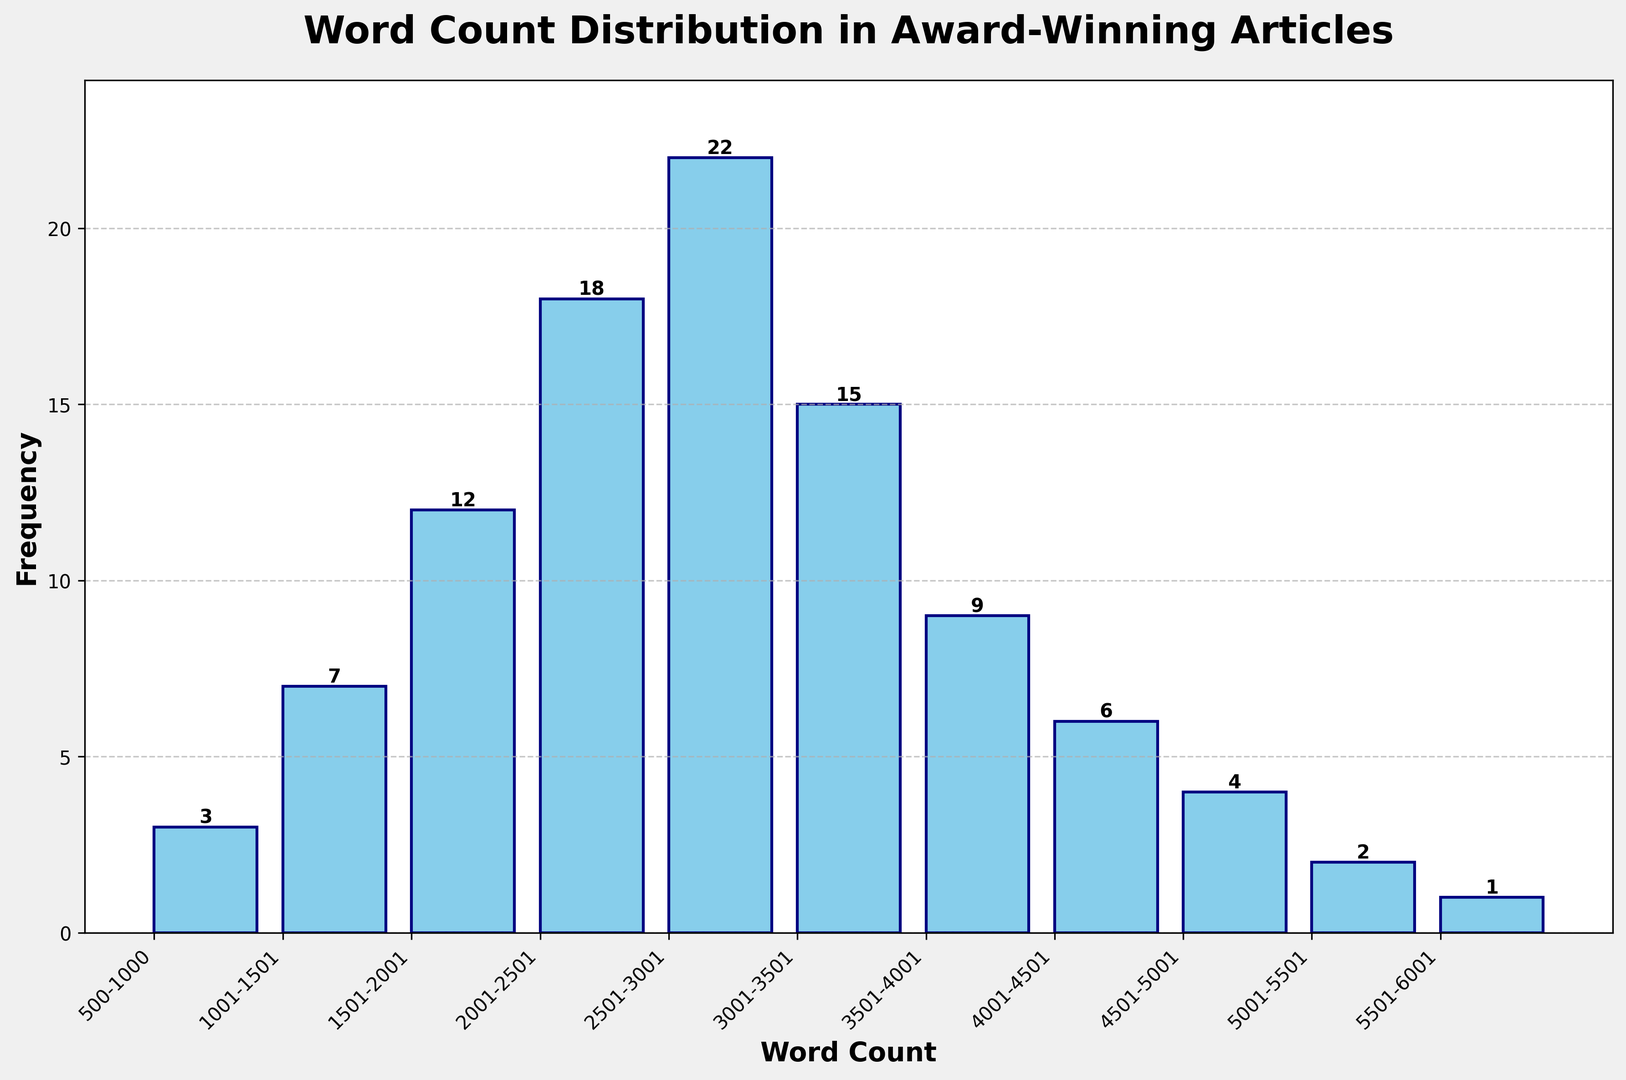What is the most frequent word count range? The bar representing the word count range 2501-3000 is the tallest, which means it has the highest frequency.
Answer: 2501-3000 What is the total frequency of articles with word counts between 1501 and 2500? Sum the frequencies of the ranges 1501-2000 (12 articles) and 2001-2500 (18 articles), which results in 12 + 18 = 30 articles.
Answer: 30 Are there more articles with word counts between 3001-4000 or 1001-2000? Compare the frequencies of ranges 3001-3500 (15 articles) and 3501-4000 (9 articles) to the frequencies of 1001-1500 (7 articles) and 1501-2000 (12 articles). Total for 3001-4000 is 15 + 9 = 24, while total for 1001-2000 is 7 + 12 = 19.
Answer: 3001-4000 What is the frequency of the shortest word count range? The smallest word count range 500-1000 has the shortest bar with a frequency of 3 articles.
Answer: 3 Which word count range appears to decline the most in frequency compared to its immediate previous range? Observe the bars and see that the range 3001-3500 (15 articles) followed by 3501-4000 (9 articles) has the largest drop of 15 - 9 = 6 articles.
Answer: 3501-4000 What is the average word count range frequency? Sum all the frequencies: (3 + 7 + 12 + 18 + 22 + 15 + 9 + 6 + 4 + 2 + 1 = 99 articles), then divide by the number of ranges (11). The average is 99 / 11 ≈ 9 articles.
Answer: 9 How many word count ranges have a frequency higher than 10? Check bars higher than 10: 1501-2000 (12 articles), 2001-2500 (18 articles), 2501-3000 (22 articles), and 3001-3500 (15 articles) make up 4 ranges.
Answer: 4 What is the difference between the highest and lowest frequencies? Subtract the smallest frequency (5501-6000: 1 article) from the largest (2501-3000: 22 articles) to get 22 - 1 = 21 articles.
Answer: 21 Which word count range has a frequency closest to the median frequency? Arrange the frequencies (1, 2, 3, 4, 6, 7, 9, 12, 15, 18, 22). The median frequency is the 6th value, which is 7, corresponding to the range 1001-1500.
Answer: 1001-1500 